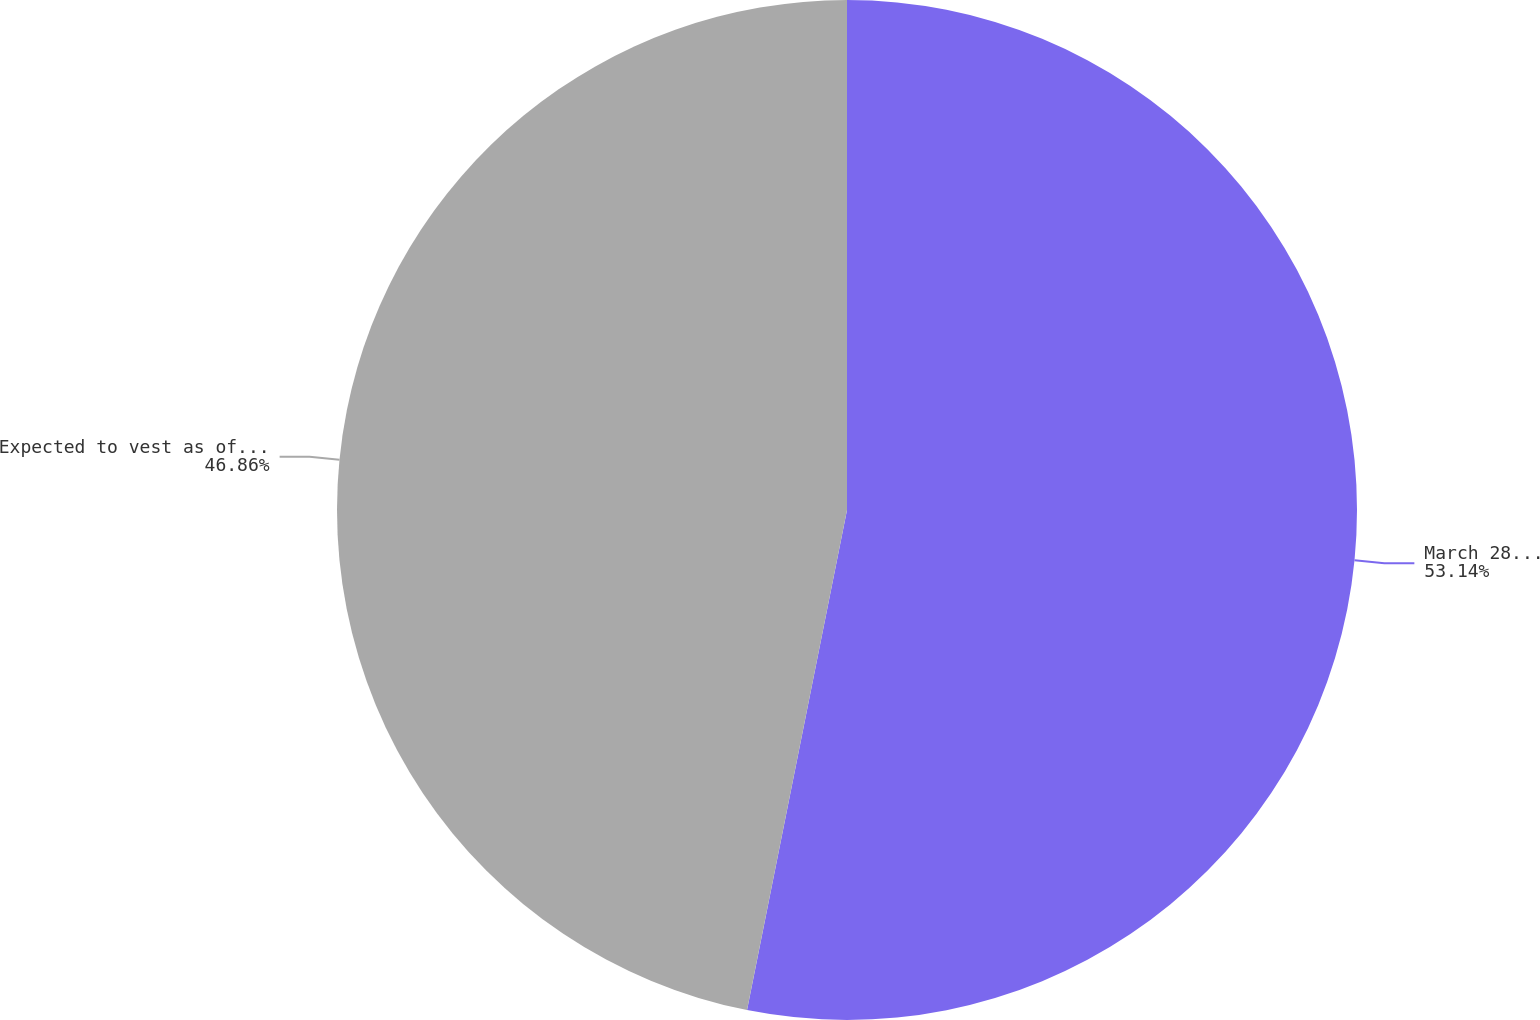Convert chart to OTSL. <chart><loc_0><loc_0><loc_500><loc_500><pie_chart><fcel>March 28 2009<fcel>Expected to vest as of March<nl><fcel>53.14%<fcel>46.86%<nl></chart> 